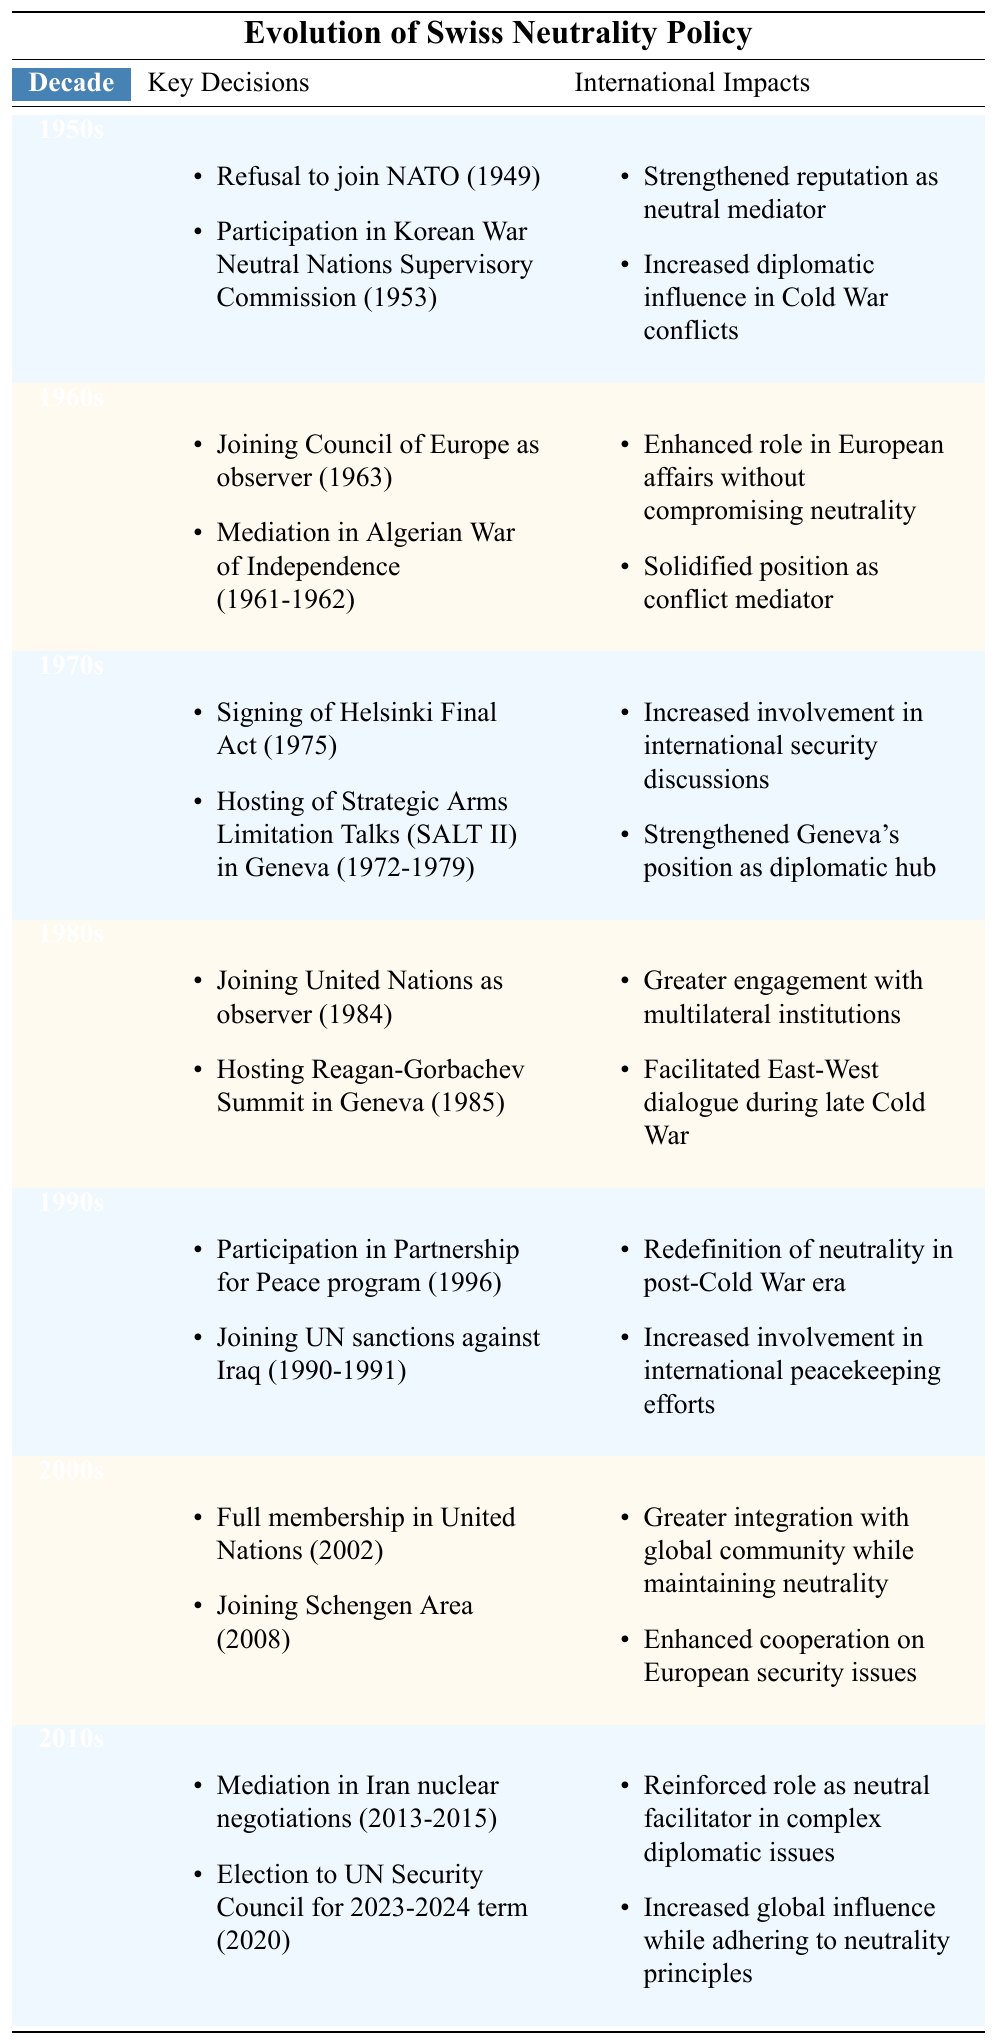What were the key decisions made by Switzerland regarding neutrality in the 1970s? In the 1970s, Switzerland made two key decisions: signing the Helsinki Final Act in 1975 and hosting the Strategic Arms Limitation Talks (SALT II) in Geneva from 1972 to 1979.
Answer: Signing the Helsinki Final Act and hosting SALT II Which decade saw Switzerland participate in the Korean War Neutral Nations Supervisory Commission? According to the table, Switzerland participated in the Korean War Neutral Nations Supervisory Commission in the 1950s.
Answer: The 1950s Did Switzerland join the United Nations as a full member in the 1990s? The table indicates that Switzerland joined the United Nations as a full member in 2002, which is in the 2000s, not the 1990s.
Answer: No How did Switzerland’s decision to join the Schengen Area impact its international standing? Joining the Schengen Area in 2008 led to greater integration with the global community while maintaining neutrality, and enhanced cooperation on European security issues.
Answer: It enhanced global integration while maintaining neutrality What was a significant international impact of Switzerland's decision to mediate in the Iran nuclear negotiations? The mediation in Iran nuclear negotiations (2013-2015) reinforced Switzerland's role as a neutral facilitator in complex diplomatic issues and increased its global influence while adhering to neutrality principles.
Answer: It reinforced Switzerland's neutral facilitator role and increased global influence How many decades involved Switzerland hosting significant international talks? The table lists hosting events in the 1970s (SALT II) and the 1980s (Reagan-Gorbachev Summit), making a total of two decades.
Answer: Two decades What pattern can be observed in Switzerland's neutrality policy over the decades? Switzerland appears to strengthen its role as a neutral facilitator over time, participating in important diplomacy and international discussions, while consistently maintaining its neutrality principles.
Answer: Strengthening neutral facilitation while maintaining neutrality 